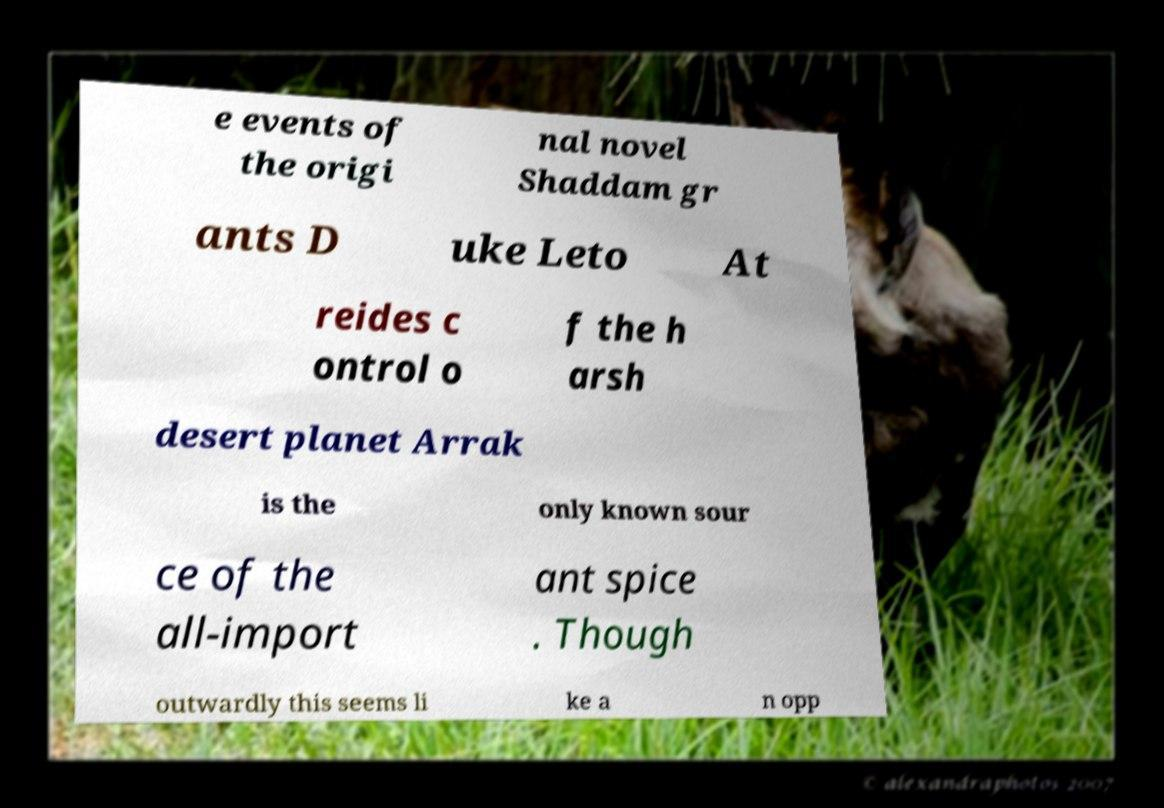Please read and relay the text visible in this image. What does it say? e events of the origi nal novel Shaddam gr ants D uke Leto At reides c ontrol o f the h arsh desert planet Arrak is the only known sour ce of the all-import ant spice . Though outwardly this seems li ke a n opp 